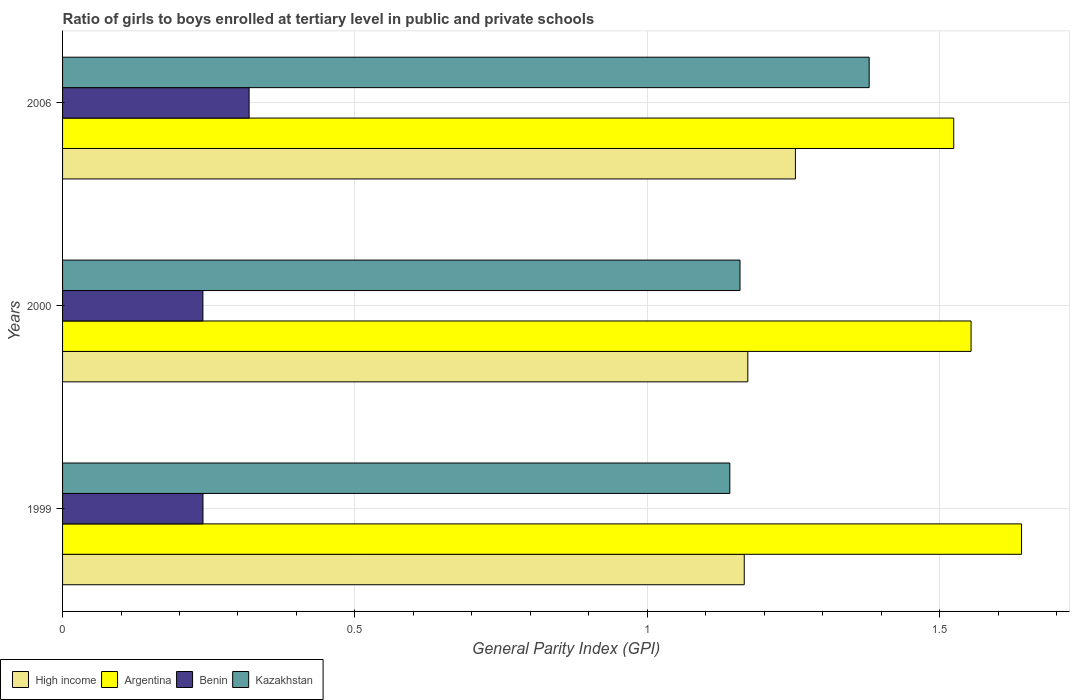How many different coloured bars are there?
Make the answer very short. 4. How many groups of bars are there?
Provide a succinct answer. 3. Are the number of bars per tick equal to the number of legend labels?
Offer a terse response. Yes. Are the number of bars on each tick of the Y-axis equal?
Ensure brevity in your answer.  Yes. How many bars are there on the 3rd tick from the top?
Provide a short and direct response. 4. In how many cases, is the number of bars for a given year not equal to the number of legend labels?
Provide a short and direct response. 0. What is the general parity index in Argentina in 1999?
Your answer should be compact. 1.64. Across all years, what is the maximum general parity index in High income?
Provide a succinct answer. 1.25. Across all years, what is the minimum general parity index in Kazakhstan?
Keep it short and to the point. 1.14. In which year was the general parity index in Argentina minimum?
Provide a succinct answer. 2006. What is the total general parity index in Kazakhstan in the graph?
Ensure brevity in your answer.  3.68. What is the difference between the general parity index in Argentina in 1999 and that in 2000?
Ensure brevity in your answer.  0.09. What is the difference between the general parity index in Benin in 2006 and the general parity index in High income in 1999?
Ensure brevity in your answer.  -0.85. What is the average general parity index in Kazakhstan per year?
Your response must be concise. 1.23. In the year 1999, what is the difference between the general parity index in Kazakhstan and general parity index in Argentina?
Provide a short and direct response. -0.5. In how many years, is the general parity index in High income greater than 1.4 ?
Your answer should be very brief. 0. What is the ratio of the general parity index in Benin in 1999 to that in 2000?
Offer a terse response. 1. Is the difference between the general parity index in Kazakhstan in 1999 and 2000 greater than the difference between the general parity index in Argentina in 1999 and 2000?
Give a very brief answer. No. What is the difference between the highest and the second highest general parity index in High income?
Ensure brevity in your answer.  0.08. What is the difference between the highest and the lowest general parity index in High income?
Ensure brevity in your answer.  0.09. Is the sum of the general parity index in Argentina in 1999 and 2006 greater than the maximum general parity index in Kazakhstan across all years?
Your answer should be compact. Yes. What does the 3rd bar from the top in 1999 represents?
Your answer should be very brief. Argentina. What does the 4th bar from the bottom in 1999 represents?
Offer a very short reply. Kazakhstan. Are all the bars in the graph horizontal?
Make the answer very short. Yes. How many years are there in the graph?
Ensure brevity in your answer.  3. What is the difference between two consecutive major ticks on the X-axis?
Your response must be concise. 0.5. Are the values on the major ticks of X-axis written in scientific E-notation?
Make the answer very short. No. Where does the legend appear in the graph?
Your response must be concise. Bottom left. How many legend labels are there?
Make the answer very short. 4. How are the legend labels stacked?
Offer a terse response. Horizontal. What is the title of the graph?
Give a very brief answer. Ratio of girls to boys enrolled at tertiary level in public and private schools. What is the label or title of the X-axis?
Your answer should be compact. General Parity Index (GPI). What is the label or title of the Y-axis?
Provide a succinct answer. Years. What is the General Parity Index (GPI) of High income in 1999?
Provide a short and direct response. 1.17. What is the General Parity Index (GPI) of Argentina in 1999?
Your answer should be compact. 1.64. What is the General Parity Index (GPI) of Benin in 1999?
Offer a terse response. 0.24. What is the General Parity Index (GPI) in Kazakhstan in 1999?
Ensure brevity in your answer.  1.14. What is the General Parity Index (GPI) in High income in 2000?
Keep it short and to the point. 1.17. What is the General Parity Index (GPI) in Argentina in 2000?
Keep it short and to the point. 1.55. What is the General Parity Index (GPI) in Benin in 2000?
Ensure brevity in your answer.  0.24. What is the General Parity Index (GPI) of Kazakhstan in 2000?
Offer a terse response. 1.16. What is the General Parity Index (GPI) of High income in 2006?
Make the answer very short. 1.25. What is the General Parity Index (GPI) of Argentina in 2006?
Keep it short and to the point. 1.52. What is the General Parity Index (GPI) of Benin in 2006?
Your answer should be very brief. 0.32. What is the General Parity Index (GPI) of Kazakhstan in 2006?
Give a very brief answer. 1.38. Across all years, what is the maximum General Parity Index (GPI) in High income?
Make the answer very short. 1.25. Across all years, what is the maximum General Parity Index (GPI) in Argentina?
Keep it short and to the point. 1.64. Across all years, what is the maximum General Parity Index (GPI) of Benin?
Your response must be concise. 0.32. Across all years, what is the maximum General Parity Index (GPI) of Kazakhstan?
Give a very brief answer. 1.38. Across all years, what is the minimum General Parity Index (GPI) in High income?
Your answer should be compact. 1.17. Across all years, what is the minimum General Parity Index (GPI) in Argentina?
Offer a very short reply. 1.52. Across all years, what is the minimum General Parity Index (GPI) in Benin?
Ensure brevity in your answer.  0.24. Across all years, what is the minimum General Parity Index (GPI) of Kazakhstan?
Your answer should be compact. 1.14. What is the total General Parity Index (GPI) of High income in the graph?
Ensure brevity in your answer.  3.59. What is the total General Parity Index (GPI) in Argentina in the graph?
Give a very brief answer. 4.72. What is the total General Parity Index (GPI) of Benin in the graph?
Your answer should be very brief. 0.8. What is the total General Parity Index (GPI) in Kazakhstan in the graph?
Your response must be concise. 3.68. What is the difference between the General Parity Index (GPI) of High income in 1999 and that in 2000?
Give a very brief answer. -0.01. What is the difference between the General Parity Index (GPI) in Argentina in 1999 and that in 2000?
Your answer should be very brief. 0.09. What is the difference between the General Parity Index (GPI) in Benin in 1999 and that in 2000?
Make the answer very short. 0. What is the difference between the General Parity Index (GPI) of Kazakhstan in 1999 and that in 2000?
Offer a very short reply. -0.02. What is the difference between the General Parity Index (GPI) in High income in 1999 and that in 2006?
Make the answer very short. -0.09. What is the difference between the General Parity Index (GPI) of Argentina in 1999 and that in 2006?
Provide a short and direct response. 0.12. What is the difference between the General Parity Index (GPI) of Benin in 1999 and that in 2006?
Your answer should be very brief. -0.08. What is the difference between the General Parity Index (GPI) in Kazakhstan in 1999 and that in 2006?
Your answer should be compact. -0.24. What is the difference between the General Parity Index (GPI) of High income in 2000 and that in 2006?
Keep it short and to the point. -0.08. What is the difference between the General Parity Index (GPI) of Argentina in 2000 and that in 2006?
Offer a terse response. 0.03. What is the difference between the General Parity Index (GPI) of Benin in 2000 and that in 2006?
Your answer should be compact. -0.08. What is the difference between the General Parity Index (GPI) of Kazakhstan in 2000 and that in 2006?
Offer a very short reply. -0.22. What is the difference between the General Parity Index (GPI) of High income in 1999 and the General Parity Index (GPI) of Argentina in 2000?
Your response must be concise. -0.39. What is the difference between the General Parity Index (GPI) of High income in 1999 and the General Parity Index (GPI) of Benin in 2000?
Give a very brief answer. 0.93. What is the difference between the General Parity Index (GPI) of High income in 1999 and the General Parity Index (GPI) of Kazakhstan in 2000?
Your answer should be compact. 0.01. What is the difference between the General Parity Index (GPI) in Argentina in 1999 and the General Parity Index (GPI) in Kazakhstan in 2000?
Provide a succinct answer. 0.48. What is the difference between the General Parity Index (GPI) in Benin in 1999 and the General Parity Index (GPI) in Kazakhstan in 2000?
Offer a very short reply. -0.92. What is the difference between the General Parity Index (GPI) in High income in 1999 and the General Parity Index (GPI) in Argentina in 2006?
Give a very brief answer. -0.36. What is the difference between the General Parity Index (GPI) in High income in 1999 and the General Parity Index (GPI) in Benin in 2006?
Your answer should be compact. 0.85. What is the difference between the General Parity Index (GPI) in High income in 1999 and the General Parity Index (GPI) in Kazakhstan in 2006?
Offer a terse response. -0.21. What is the difference between the General Parity Index (GPI) in Argentina in 1999 and the General Parity Index (GPI) in Benin in 2006?
Provide a succinct answer. 1.32. What is the difference between the General Parity Index (GPI) of Argentina in 1999 and the General Parity Index (GPI) of Kazakhstan in 2006?
Provide a short and direct response. 0.26. What is the difference between the General Parity Index (GPI) in Benin in 1999 and the General Parity Index (GPI) in Kazakhstan in 2006?
Your answer should be very brief. -1.14. What is the difference between the General Parity Index (GPI) of High income in 2000 and the General Parity Index (GPI) of Argentina in 2006?
Keep it short and to the point. -0.35. What is the difference between the General Parity Index (GPI) in High income in 2000 and the General Parity Index (GPI) in Benin in 2006?
Keep it short and to the point. 0.85. What is the difference between the General Parity Index (GPI) in High income in 2000 and the General Parity Index (GPI) in Kazakhstan in 2006?
Make the answer very short. -0.21. What is the difference between the General Parity Index (GPI) in Argentina in 2000 and the General Parity Index (GPI) in Benin in 2006?
Offer a terse response. 1.23. What is the difference between the General Parity Index (GPI) of Argentina in 2000 and the General Parity Index (GPI) of Kazakhstan in 2006?
Make the answer very short. 0.17. What is the difference between the General Parity Index (GPI) in Benin in 2000 and the General Parity Index (GPI) in Kazakhstan in 2006?
Give a very brief answer. -1.14. What is the average General Parity Index (GPI) in High income per year?
Provide a short and direct response. 1.2. What is the average General Parity Index (GPI) in Argentina per year?
Provide a short and direct response. 1.57. What is the average General Parity Index (GPI) in Benin per year?
Provide a succinct answer. 0.27. What is the average General Parity Index (GPI) in Kazakhstan per year?
Make the answer very short. 1.23. In the year 1999, what is the difference between the General Parity Index (GPI) of High income and General Parity Index (GPI) of Argentina?
Provide a short and direct response. -0.47. In the year 1999, what is the difference between the General Parity Index (GPI) of High income and General Parity Index (GPI) of Benin?
Make the answer very short. 0.93. In the year 1999, what is the difference between the General Parity Index (GPI) in High income and General Parity Index (GPI) in Kazakhstan?
Keep it short and to the point. 0.02. In the year 1999, what is the difference between the General Parity Index (GPI) in Argentina and General Parity Index (GPI) in Benin?
Give a very brief answer. 1.4. In the year 1999, what is the difference between the General Parity Index (GPI) of Argentina and General Parity Index (GPI) of Kazakhstan?
Give a very brief answer. 0.5. In the year 1999, what is the difference between the General Parity Index (GPI) of Benin and General Parity Index (GPI) of Kazakhstan?
Your answer should be very brief. -0.9. In the year 2000, what is the difference between the General Parity Index (GPI) of High income and General Parity Index (GPI) of Argentina?
Provide a short and direct response. -0.38. In the year 2000, what is the difference between the General Parity Index (GPI) in High income and General Parity Index (GPI) in Benin?
Offer a very short reply. 0.93. In the year 2000, what is the difference between the General Parity Index (GPI) of High income and General Parity Index (GPI) of Kazakhstan?
Provide a succinct answer. 0.01. In the year 2000, what is the difference between the General Parity Index (GPI) in Argentina and General Parity Index (GPI) in Benin?
Ensure brevity in your answer.  1.31. In the year 2000, what is the difference between the General Parity Index (GPI) in Argentina and General Parity Index (GPI) in Kazakhstan?
Offer a terse response. 0.4. In the year 2000, what is the difference between the General Parity Index (GPI) of Benin and General Parity Index (GPI) of Kazakhstan?
Keep it short and to the point. -0.92. In the year 2006, what is the difference between the General Parity Index (GPI) in High income and General Parity Index (GPI) in Argentina?
Offer a terse response. -0.27. In the year 2006, what is the difference between the General Parity Index (GPI) in High income and General Parity Index (GPI) in Benin?
Make the answer very short. 0.93. In the year 2006, what is the difference between the General Parity Index (GPI) of High income and General Parity Index (GPI) of Kazakhstan?
Offer a very short reply. -0.13. In the year 2006, what is the difference between the General Parity Index (GPI) in Argentina and General Parity Index (GPI) in Benin?
Your response must be concise. 1.21. In the year 2006, what is the difference between the General Parity Index (GPI) in Argentina and General Parity Index (GPI) in Kazakhstan?
Provide a short and direct response. 0.14. In the year 2006, what is the difference between the General Parity Index (GPI) of Benin and General Parity Index (GPI) of Kazakhstan?
Offer a terse response. -1.06. What is the ratio of the General Parity Index (GPI) in High income in 1999 to that in 2000?
Keep it short and to the point. 0.99. What is the ratio of the General Parity Index (GPI) of Argentina in 1999 to that in 2000?
Your response must be concise. 1.06. What is the ratio of the General Parity Index (GPI) in Benin in 1999 to that in 2000?
Provide a short and direct response. 1. What is the ratio of the General Parity Index (GPI) in Kazakhstan in 1999 to that in 2000?
Offer a very short reply. 0.98. What is the ratio of the General Parity Index (GPI) in High income in 1999 to that in 2006?
Provide a succinct answer. 0.93. What is the ratio of the General Parity Index (GPI) of Argentina in 1999 to that in 2006?
Provide a short and direct response. 1.08. What is the ratio of the General Parity Index (GPI) of Benin in 1999 to that in 2006?
Give a very brief answer. 0.75. What is the ratio of the General Parity Index (GPI) of Kazakhstan in 1999 to that in 2006?
Make the answer very short. 0.83. What is the ratio of the General Parity Index (GPI) of High income in 2000 to that in 2006?
Provide a short and direct response. 0.94. What is the ratio of the General Parity Index (GPI) in Argentina in 2000 to that in 2006?
Provide a succinct answer. 1.02. What is the ratio of the General Parity Index (GPI) in Benin in 2000 to that in 2006?
Provide a succinct answer. 0.75. What is the ratio of the General Parity Index (GPI) in Kazakhstan in 2000 to that in 2006?
Offer a terse response. 0.84. What is the difference between the highest and the second highest General Parity Index (GPI) in High income?
Ensure brevity in your answer.  0.08. What is the difference between the highest and the second highest General Parity Index (GPI) of Argentina?
Make the answer very short. 0.09. What is the difference between the highest and the second highest General Parity Index (GPI) of Benin?
Make the answer very short. 0.08. What is the difference between the highest and the second highest General Parity Index (GPI) in Kazakhstan?
Offer a very short reply. 0.22. What is the difference between the highest and the lowest General Parity Index (GPI) in High income?
Make the answer very short. 0.09. What is the difference between the highest and the lowest General Parity Index (GPI) of Argentina?
Provide a short and direct response. 0.12. What is the difference between the highest and the lowest General Parity Index (GPI) of Benin?
Provide a succinct answer. 0.08. What is the difference between the highest and the lowest General Parity Index (GPI) in Kazakhstan?
Make the answer very short. 0.24. 